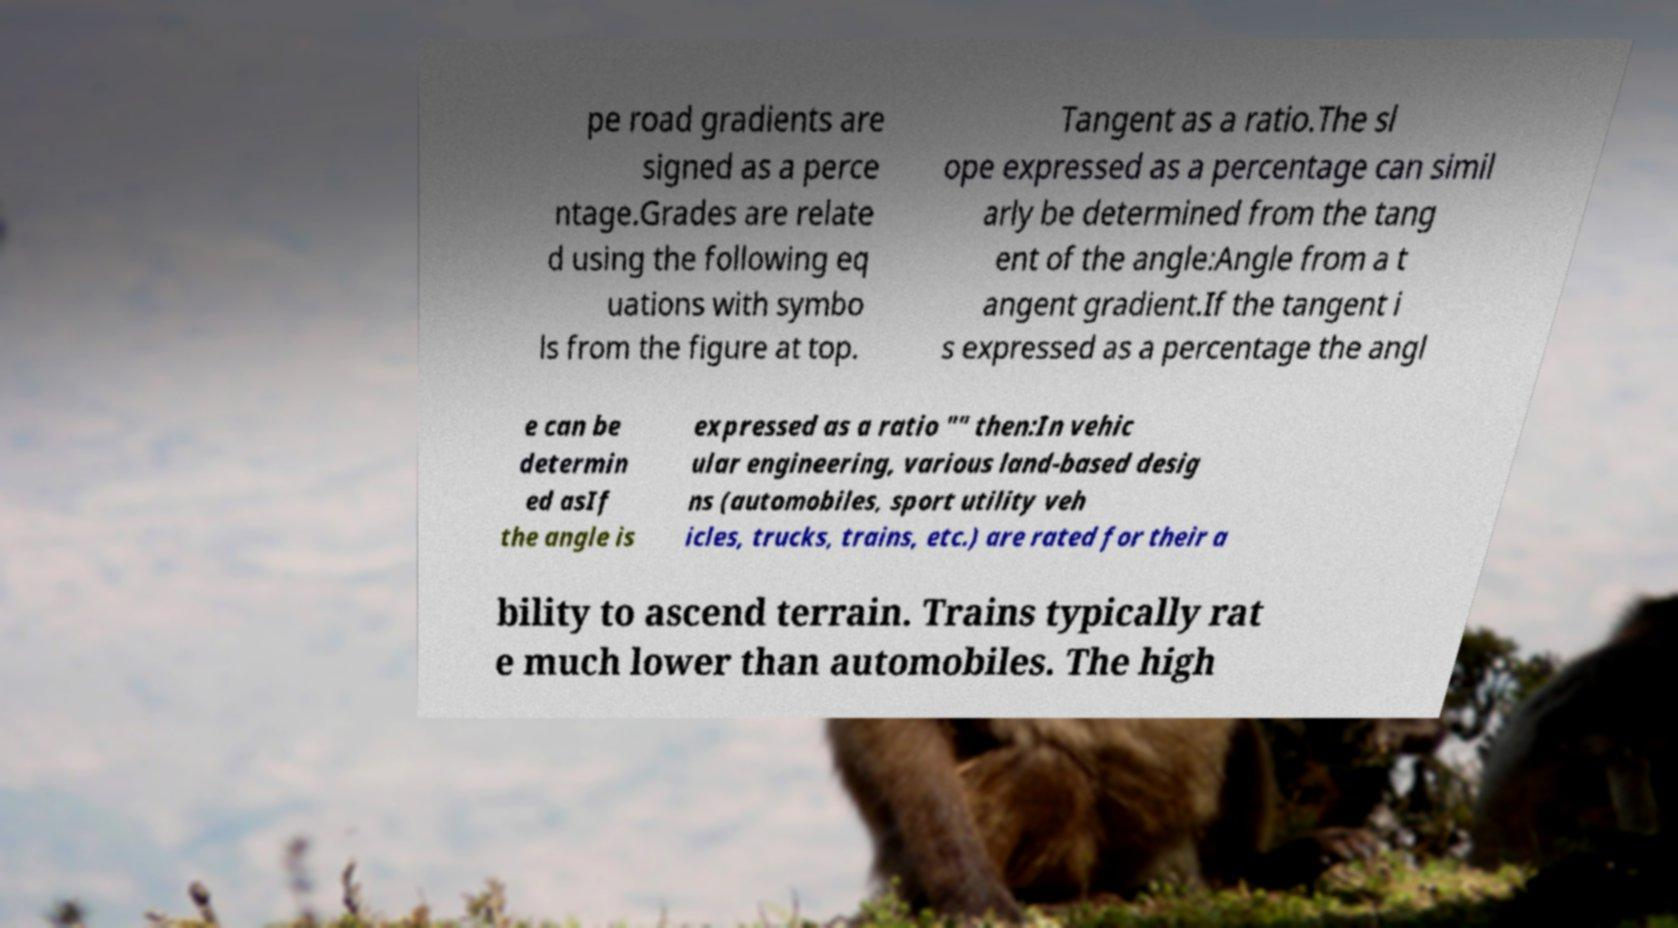Could you assist in decoding the text presented in this image and type it out clearly? pe road gradients are signed as a perce ntage.Grades are relate d using the following eq uations with symbo ls from the figure at top. Tangent as a ratio.The sl ope expressed as a percentage can simil arly be determined from the tang ent of the angle:Angle from a t angent gradient.If the tangent i s expressed as a percentage the angl e can be determin ed asIf the angle is expressed as a ratio "" then:In vehic ular engineering, various land-based desig ns (automobiles, sport utility veh icles, trucks, trains, etc.) are rated for their a bility to ascend terrain. Trains typically rat e much lower than automobiles. The high 